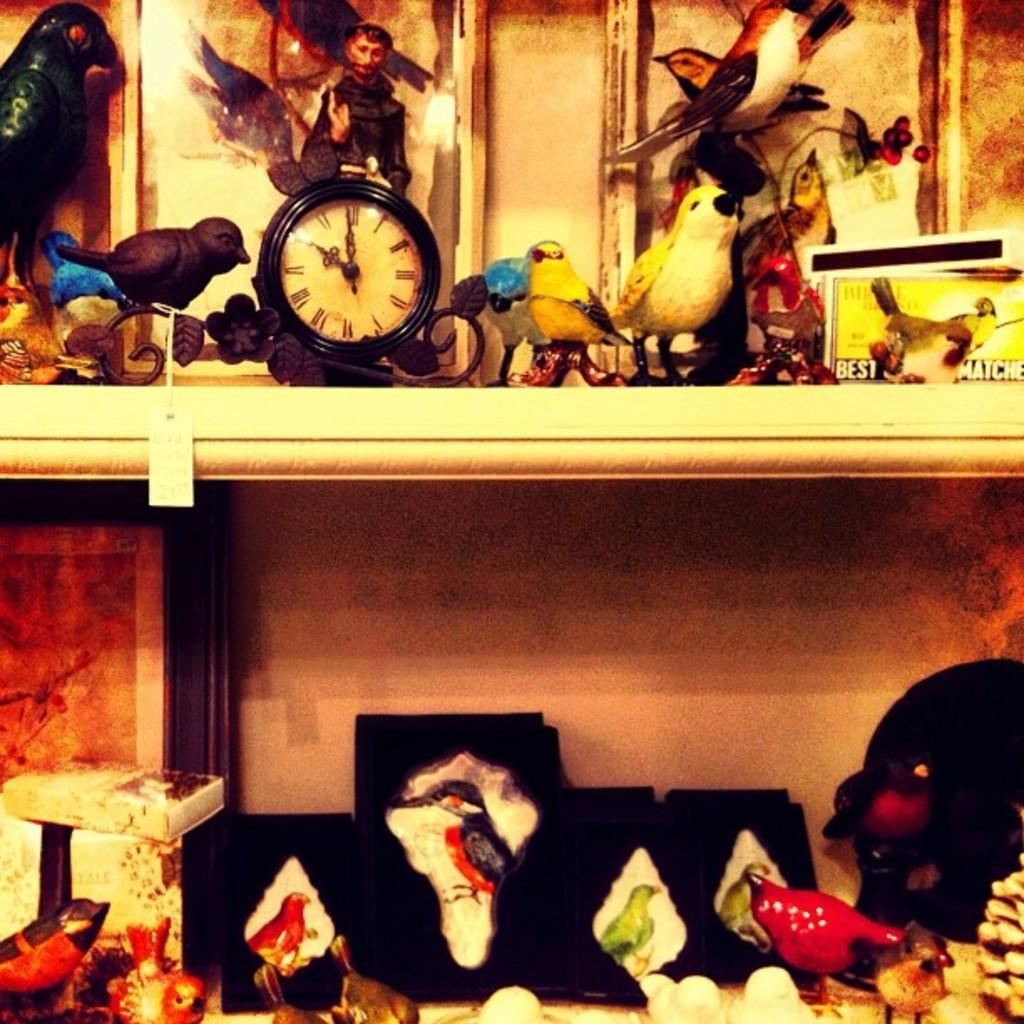What object in the image tells the time? There is a clock in the image that tells the time. Where is the clock located in the image? The clock is on a shelf in the image. What else can be seen on the shelves in the image? There are toys arranged on the shelves in the image. How are the toys organized on the shelves? The toys are arranged in shelves in the image. What type of boundary is visible in the image? There is no boundary visible in the image. How many dolls are present in the image? There is no mention of dolls in the provided facts, so we cannot determine the number of dolls in the image. 